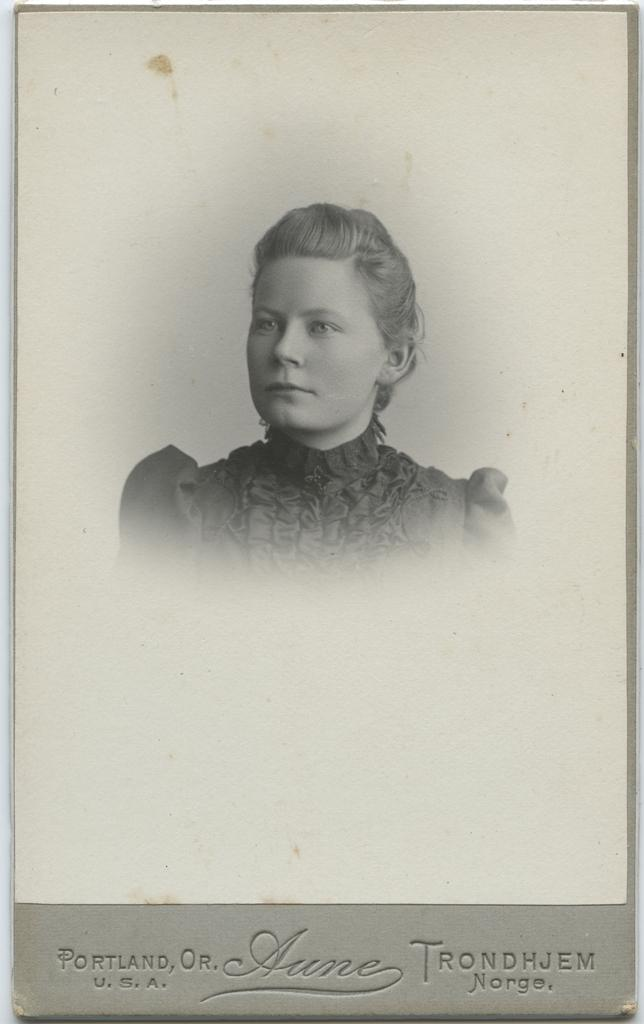What is the main subject of the image? There is a black and white picture of a woman in the image. How is the picture of the woman presented? The picture is on a piece of paper. Is there any text associated with the picture? Yes, there is text at the bottom of the picture. What type of soup is the woman eating in the image? There is no soup present in the image; it features a black and white picture of a woman on a piece of paper with text at the bottom. 